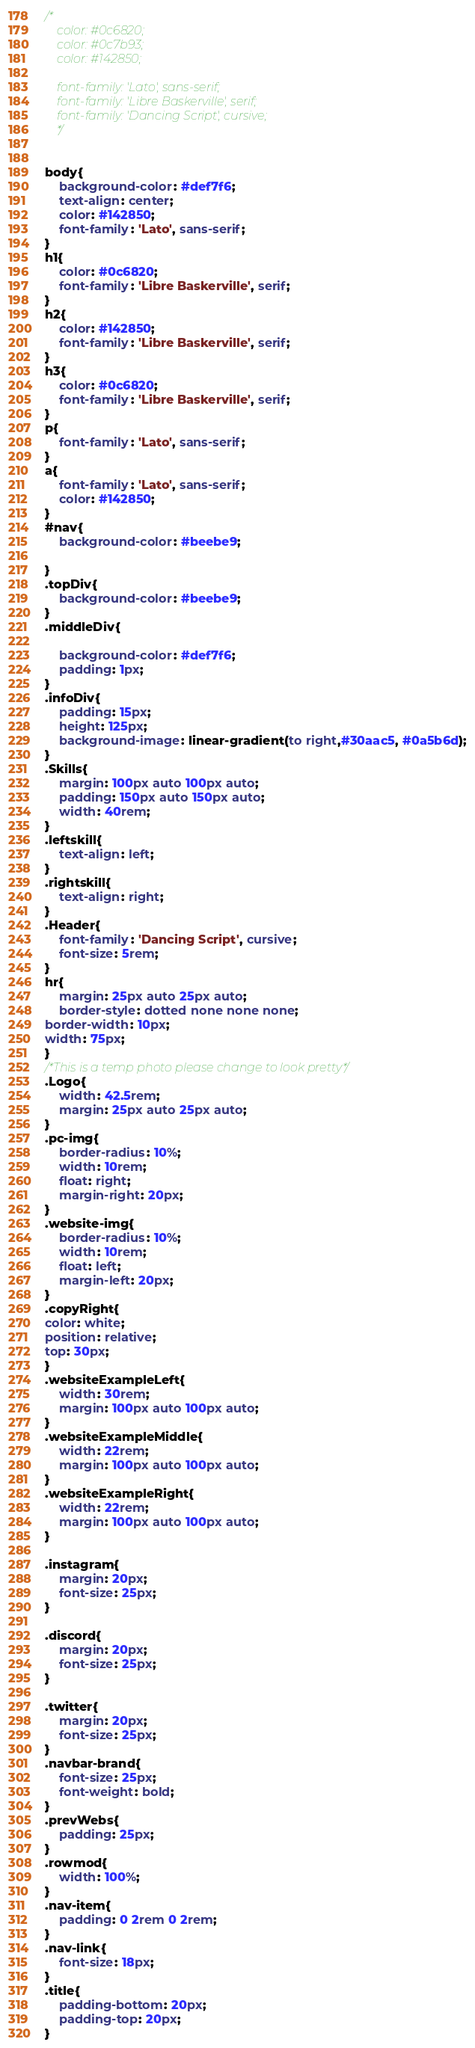Convert code to text. <code><loc_0><loc_0><loc_500><loc_500><_CSS_>
/*
    color: #0c6820;
    color: #0c7b93;
    color: #142850;

    font-family: 'Lato', sans-serif;
    font-family: 'Libre Baskerville', serif;
    font-family: 'Dancing Script', cursive;
    */


body{
    background-color: #def7f6;
    text-align: center;
    color: #142850;
    font-family: 'Lato', sans-serif;
}
h1{
    color: #0c6820;
    font-family: 'Libre Baskerville', serif;
}
h2{
    color: #142850;
    font-family: 'Libre Baskerville', serif;
}
h3{
    color: #0c6820;
    font-family: 'Libre Baskerville', serif;
}
p{
    font-family: 'Lato', sans-serif;
}
a{
    font-family: 'Lato', sans-serif;
    color: #142850;
}
#nav{
    background-color: #beebe9;

}
.topDiv{
    background-color: #beebe9;
}
.middleDiv{
    
    background-color: #def7f6;
    padding: 1px;
}
.infoDiv{
    padding: 15px;
    height: 125px;
    background-image: linear-gradient(to right,#30aac5, #0a5b6d);
}
.Skills{
    margin: 100px auto 100px auto;
    padding: 150px auto 150px auto;
    width: 40rem;
}
.leftskill{
    text-align: left;
}
.rightskill{
    text-align: right;
}
.Header{
    font-family: 'Dancing Script', cursive;
    font-size: 5rem;
}
hr{
    margin: 25px auto 25px auto;
    border-style: dotted none none none;
border-width: 10px;
width: 75px;
}
/*This is a temp photo please change to look pretty*/
.Logo{
    width: 42.5rem;
    margin: 25px auto 25px auto;
}
.pc-img{
    border-radius: 10%;
    width: 10rem;
    float: right;
    margin-right: 20px;
}
.website-img{
    border-radius: 10%;
    width: 10rem;
    float: left;
    margin-left: 20px;
}
.copyRight{
color: white;
position: relative;
top: 30px;
}
.websiteExampleLeft{
    width: 30rem;
    margin: 100px auto 100px auto;
}
.websiteExampleMiddle{
    width: 22rem;
    margin: 100px auto 100px auto;
}
.websiteExampleRight{
    width: 22rem;
    margin: 100px auto 100px auto;
}

.instagram{
    margin: 20px;
    font-size: 25px;
}

.discord{
    margin: 20px;
    font-size: 25px;
}

.twitter{
    margin: 20px;
    font-size: 25px;
}
.navbar-brand{
    font-size: 25px;
    font-weight: bold;
}
.prevWebs{
    padding: 25px;
}
.rowmod{
    width: 100%;
}
.nav-item{
    padding: 0 2rem 0 2rem;
}
.nav-link{
    font-size: 18px;
}
.title{
    padding-bottom: 20px;
    padding-top: 20px;
}</code> 